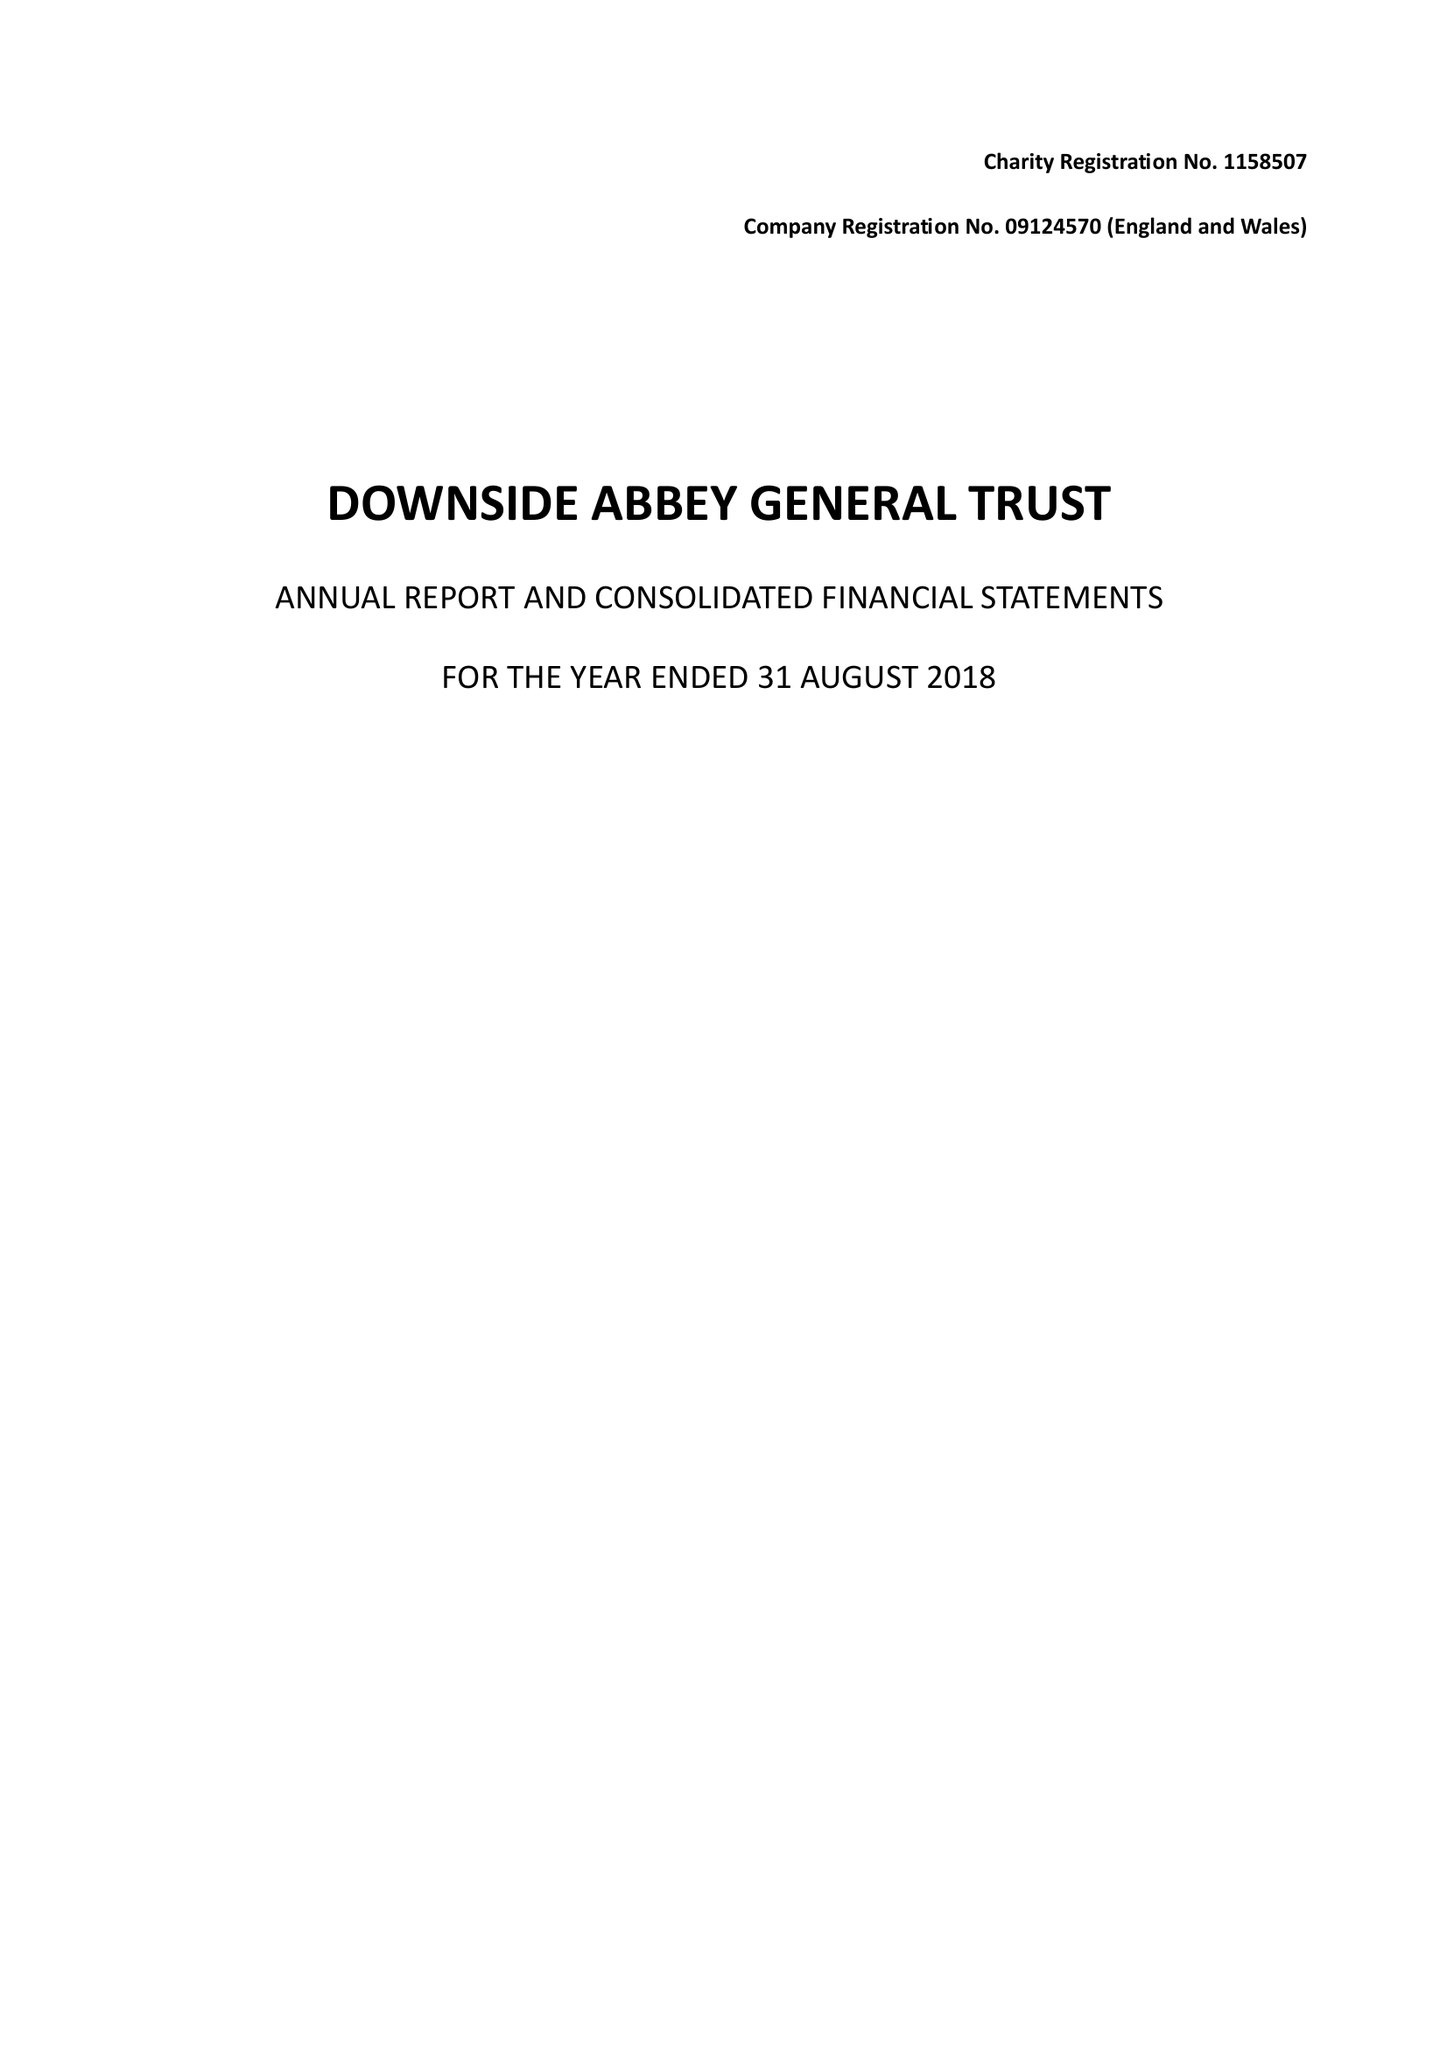What is the value for the spending_annually_in_british_pounds?
Answer the question using a single word or phrase. 12060417.00 